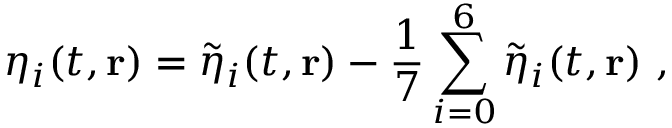<formula> <loc_0><loc_0><loc_500><loc_500>\eta _ { i } ( t , r ) = \tilde { \eta } _ { i } ( t , r ) - \frac { 1 } { 7 } \sum _ { i = 0 } ^ { 6 } \tilde { \eta } _ { i } ( t , r ) \ ,</formula> 